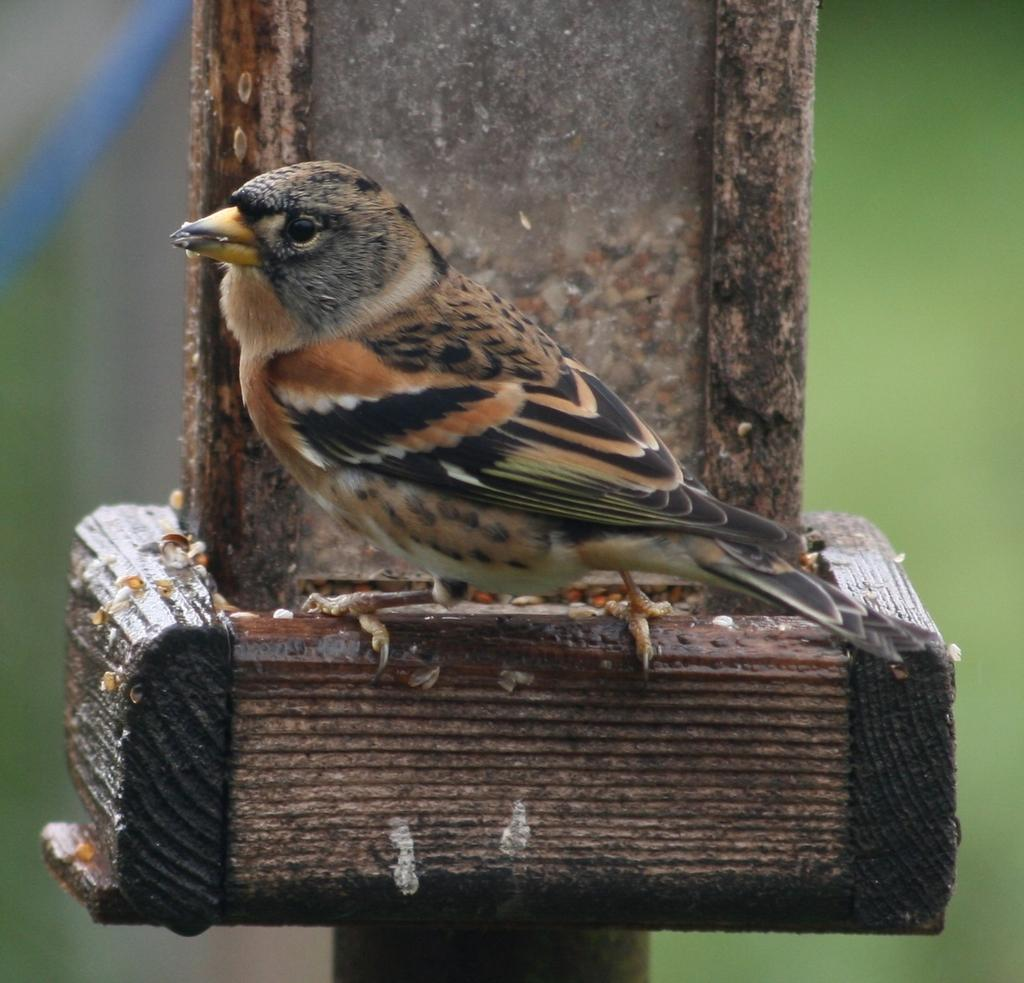What type of animal is in the image? There is a bird in the image. Where is the bird located? The bird is on a wooden object. Can you describe the background of the image? The background of the image is blurred. What color is the bird's vein in the image? There is no mention of veins in the image, and it is not possible to determine the color of a bird's vein from the image. 